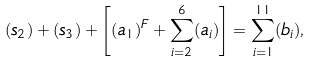Convert formula to latex. <formula><loc_0><loc_0><loc_500><loc_500>( s _ { 2 } ) + ( s _ { 3 } ) + \left [ ( a _ { 1 } ) ^ { F } + \sum _ { i = 2 } ^ { 6 } ( a _ { i } ) \right ] = \sum _ { i = 1 } ^ { 1 1 } ( b _ { i } ) ,</formula> 